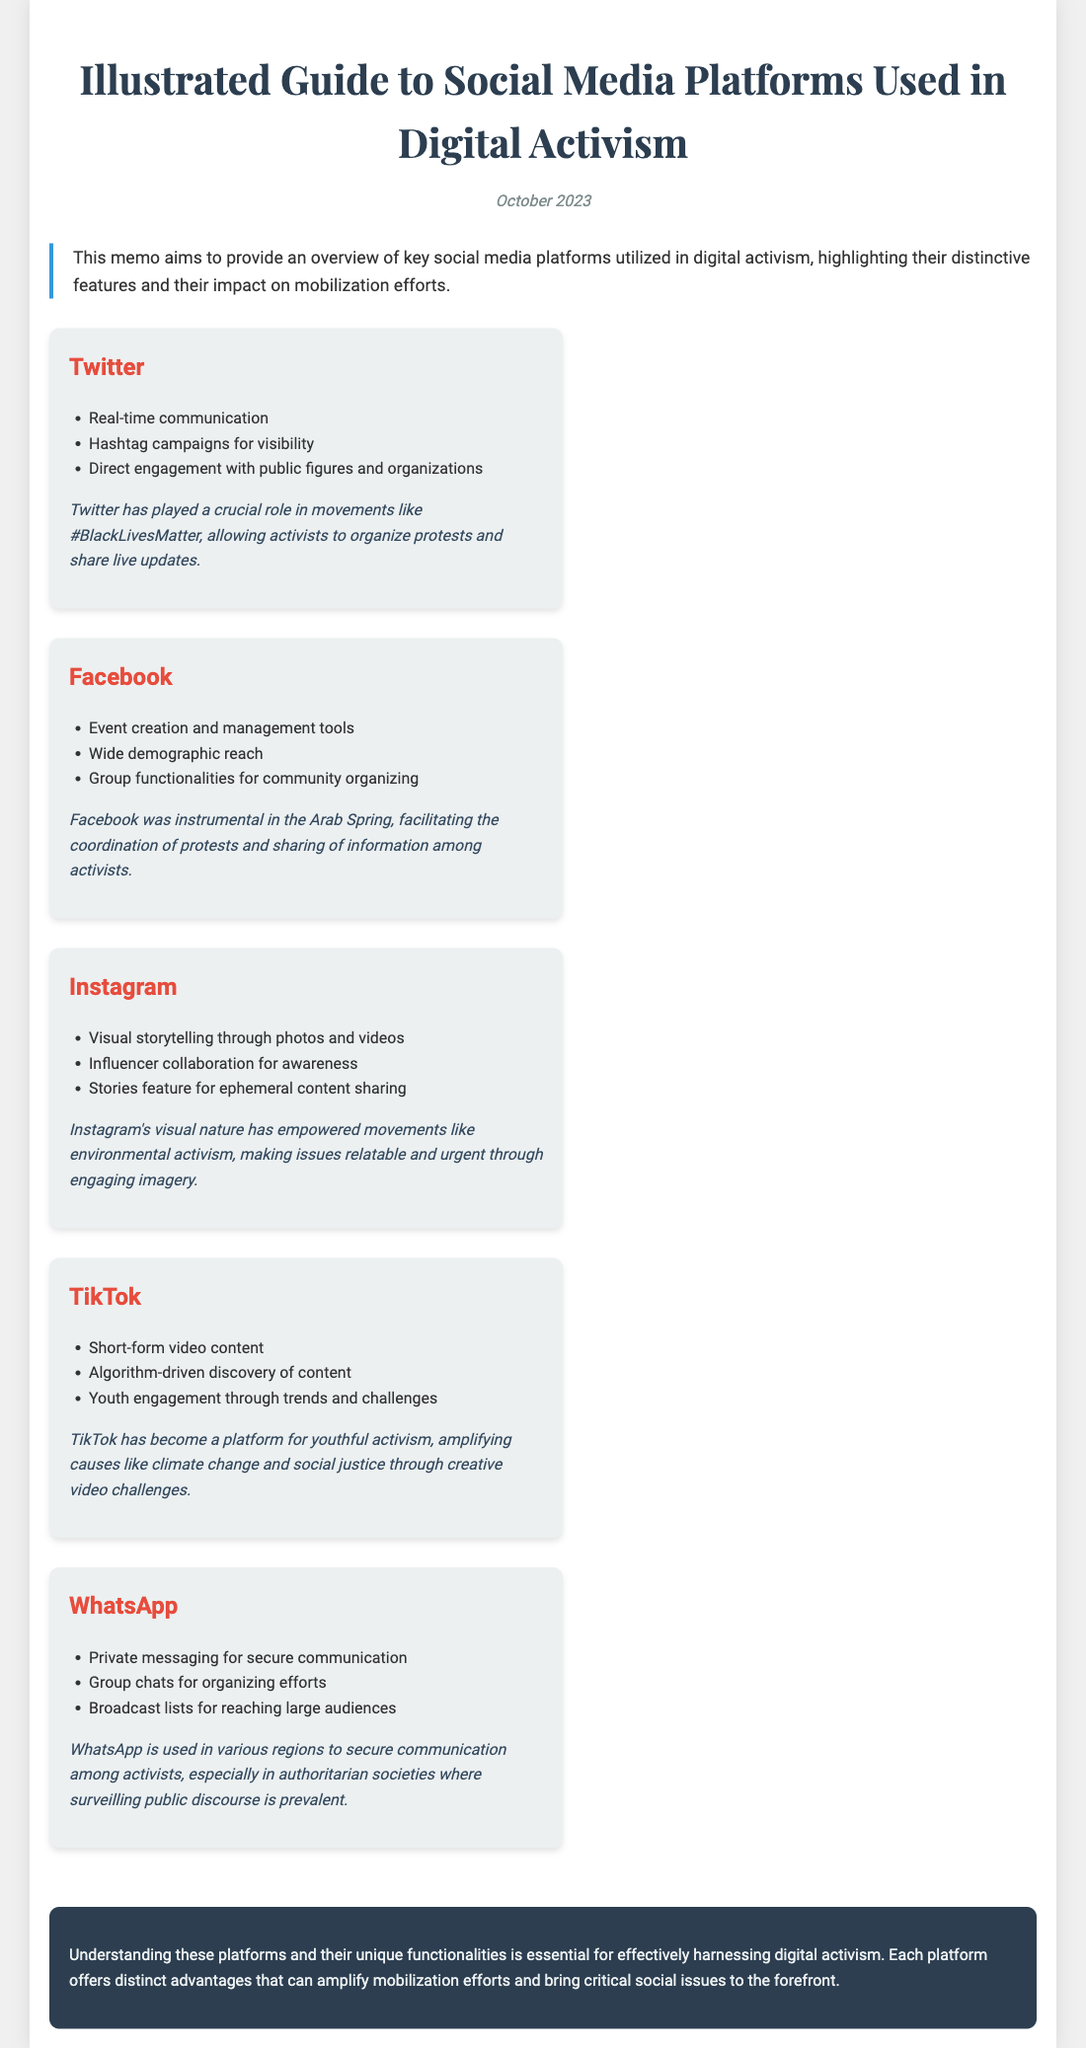What is the title of the memo? The title is found at the beginning of the document, summarizing its content.
Answer: Illustrated Guide to Social Media Platforms Used in Digital Activism What platform was instrumental in the Arab Spring? The document mentions that Facebook was key in facilitating coordination among activists during this event.
Answer: Facebook Which feature of TikTok enhances youth engagement? The document states that TikTok uses trends and challenges to engage younger audiences in activism.
Answer: Trends and challenges How many platforms are discussed in the document? The platforms listed are Twitter, Facebook, Instagram, TikTok, and WhatsApp, totaling five unique platforms.
Answer: 5 What type of content does Instagram focus on? The document highlights Instagram's emphasis on visual storytelling through specific media forms.
Answer: Photos and videos Which platform is described as using secure communication? The memo points out WhatsApp's unique feature of private messaging for secure activist communication.
Answer: WhatsApp What color is used in the document's conclusion section? The conclusion section has a distinct background color described in the design choices, making it easily identifiable.
Answer: Dark blue Which movement is associated with Twitter according to the memo? The document specifically highlights the #BlackLivesMatter movement as an example of Twitter's use in activism.
Answer: #BlackLivesMatter 